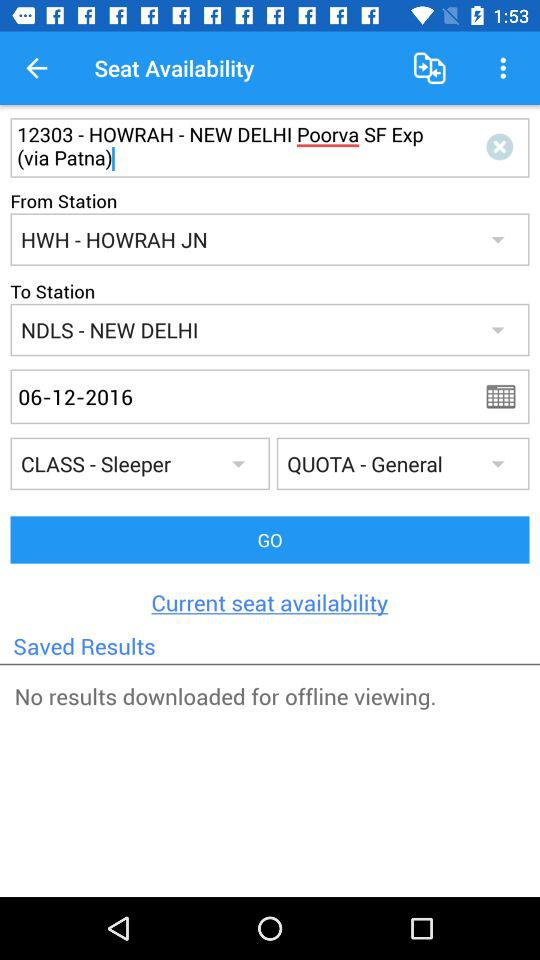What type of quota is selected? The selected type of quota is "General". 